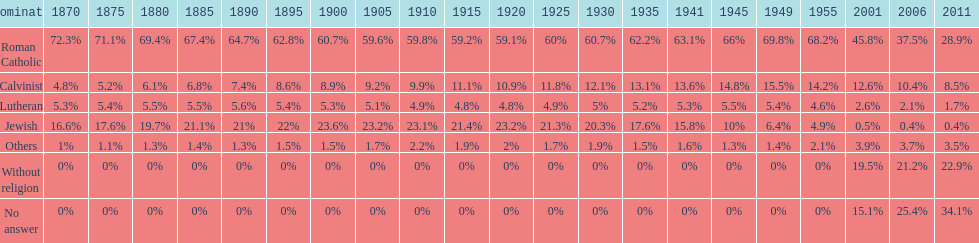Which denomination percentage increased the most after 1949? Without religion. 